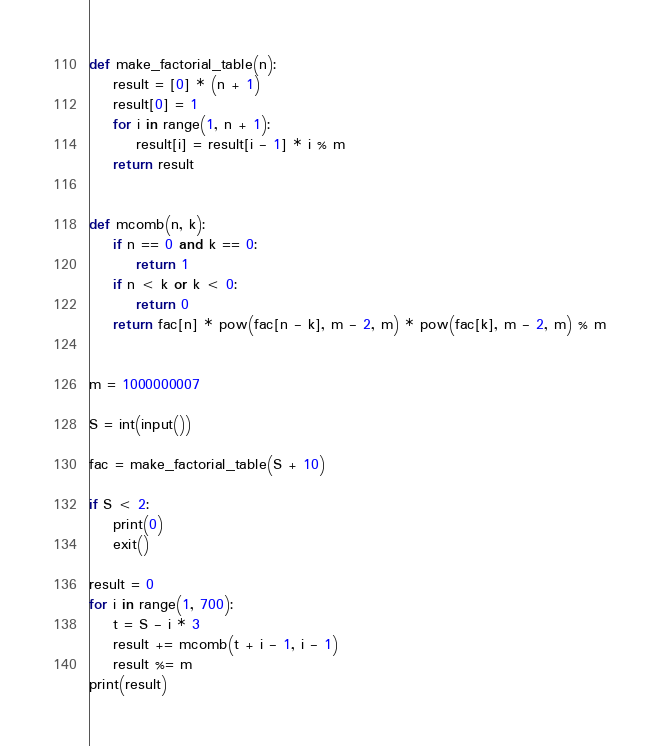Convert code to text. <code><loc_0><loc_0><loc_500><loc_500><_Python_>def make_factorial_table(n):
    result = [0] * (n + 1)
    result[0] = 1
    for i in range(1, n + 1):
        result[i] = result[i - 1] * i % m
    return result


def mcomb(n, k):
    if n == 0 and k == 0:
        return 1
    if n < k or k < 0:
        return 0
    return fac[n] * pow(fac[n - k], m - 2, m) * pow(fac[k], m - 2, m) % m


m = 1000000007

S = int(input())

fac = make_factorial_table(S + 10)

if S < 2:
    print(0)
    exit()

result = 0
for i in range(1, 700):
    t = S - i * 3
    result += mcomb(t + i - 1, i - 1)
    result %= m
print(result)
</code> 